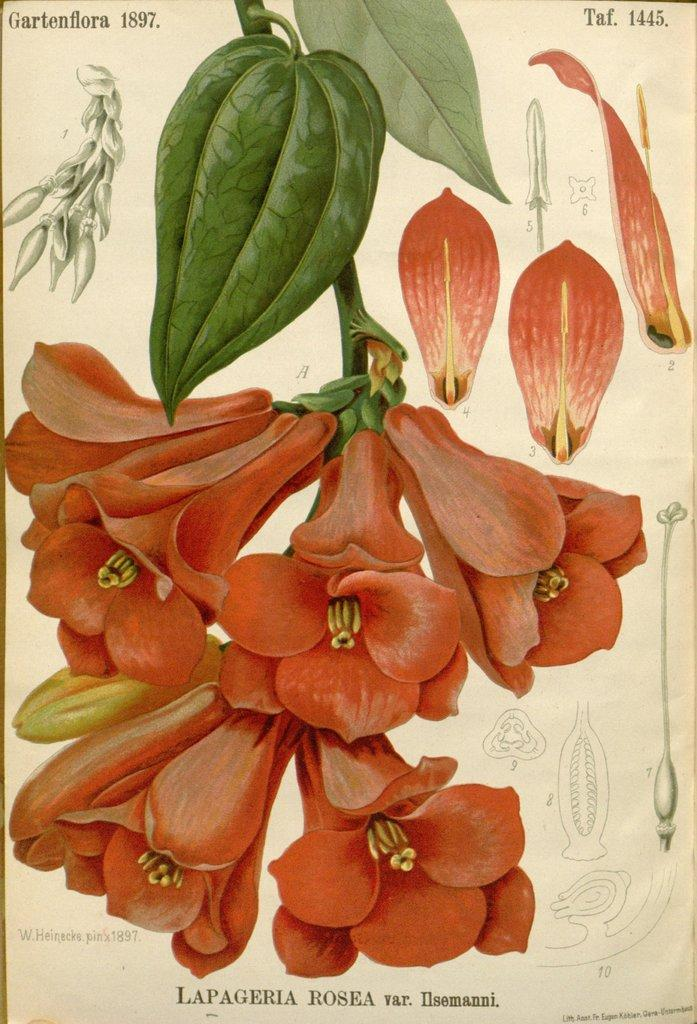What is the main subject in the center of the image? There is a paper in the center of the image. What can be seen on the paper? The paper has orange color flowers and leaves on it. Is there any text on the paper? Yes, there is writing on the paper. What type of temper can be seen on the person's wrist in the image? There is no person or wrist present in the image; it only features a paper with flowers and leaves. 